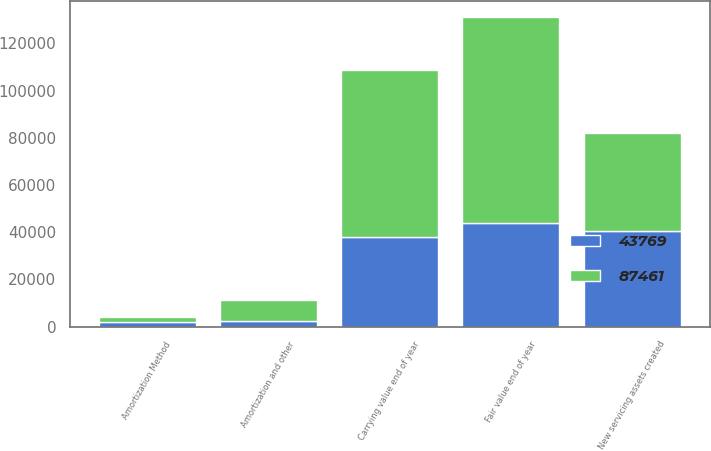Convert chart to OTSL. <chart><loc_0><loc_0><loc_500><loc_500><stacked_bar_chart><ecel><fcel>Amortization Method<fcel>New servicing assets created<fcel>Amortization and other<fcel>Carrying value end of year<fcel>Fair value end of year<nl><fcel>87461<fcel>2010<fcel>41489<fcel>9138<fcel>70516<fcel>87461<nl><fcel>43769<fcel>2009<fcel>40452<fcel>2287<fcel>38165<fcel>43769<nl></chart> 